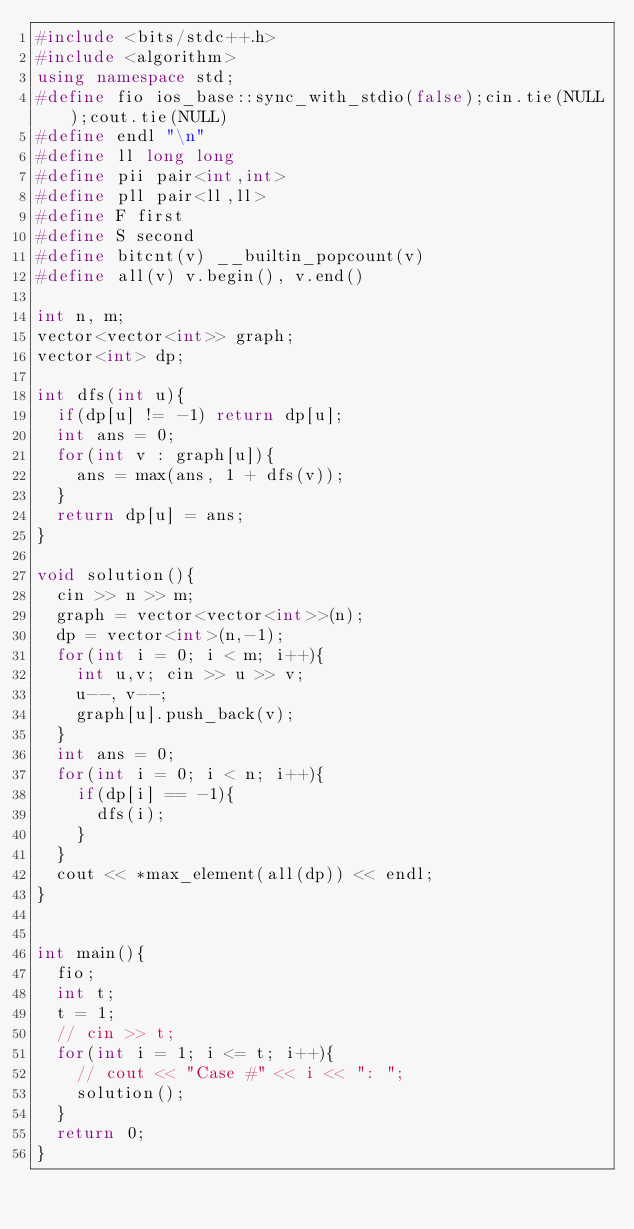<code> <loc_0><loc_0><loc_500><loc_500><_C++_>#include <bits/stdc++.h>
#include <algorithm>
using namespace std;
#define fio ios_base::sync_with_stdio(false);cin.tie(NULL);cout.tie(NULL)
#define endl "\n"
#define ll long long
#define pii pair<int,int>
#define pll pair<ll,ll>
#define F first
#define S second
#define bitcnt(v) __builtin_popcount(v)
#define all(v) v.begin(), v.end()

int n, m;
vector<vector<int>> graph;
vector<int> dp;

int dfs(int u){
	if(dp[u] != -1) return dp[u];
	int ans = 0;
	for(int v : graph[u]){
		ans = max(ans, 1 + dfs(v));
	}
	return dp[u] = ans;
}

void solution(){
	cin >> n >> m;
	graph = vector<vector<int>>(n);
	dp = vector<int>(n,-1);
	for(int i = 0; i < m; i++){
		int u,v; cin >> u >> v;
		u--, v--;
		graph[u].push_back(v);
	}
	int ans = 0;
	for(int i = 0; i < n; i++){
		if(dp[i] == -1){
			dfs(i);
		}
	}
	cout << *max_element(all(dp)) << endl;
}	


int main(){ 
	fio;
	int t;
	t = 1;
	// cin >> t;
	for(int i = 1; i <= t; i++){
		// cout << "Case #" << i << ": ";
		solution();
	} 
	return 0;
}</code> 